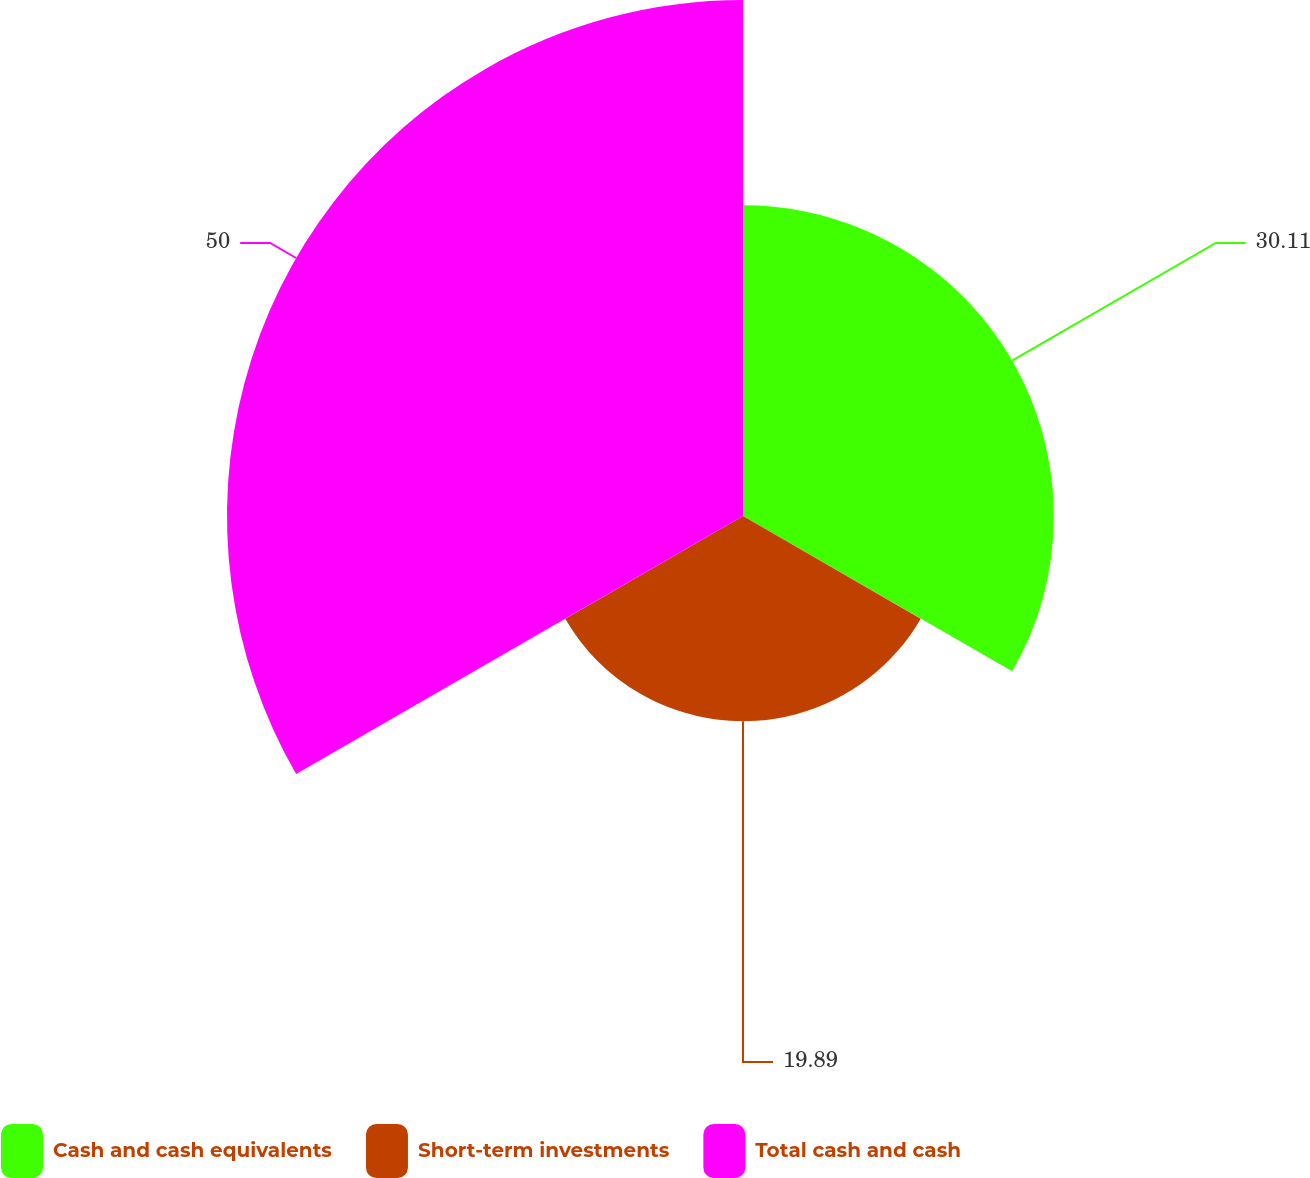Convert chart to OTSL. <chart><loc_0><loc_0><loc_500><loc_500><pie_chart><fcel>Cash and cash equivalents<fcel>Short-term investments<fcel>Total cash and cash<nl><fcel>30.11%<fcel>19.89%<fcel>50.0%<nl></chart> 